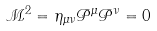<formula> <loc_0><loc_0><loc_500><loc_500>\mathcal { M } ^ { 2 } = \eta _ { \mu \nu } \mathcal { P } ^ { \mu } \mathcal { P } ^ { \nu } = 0</formula> 